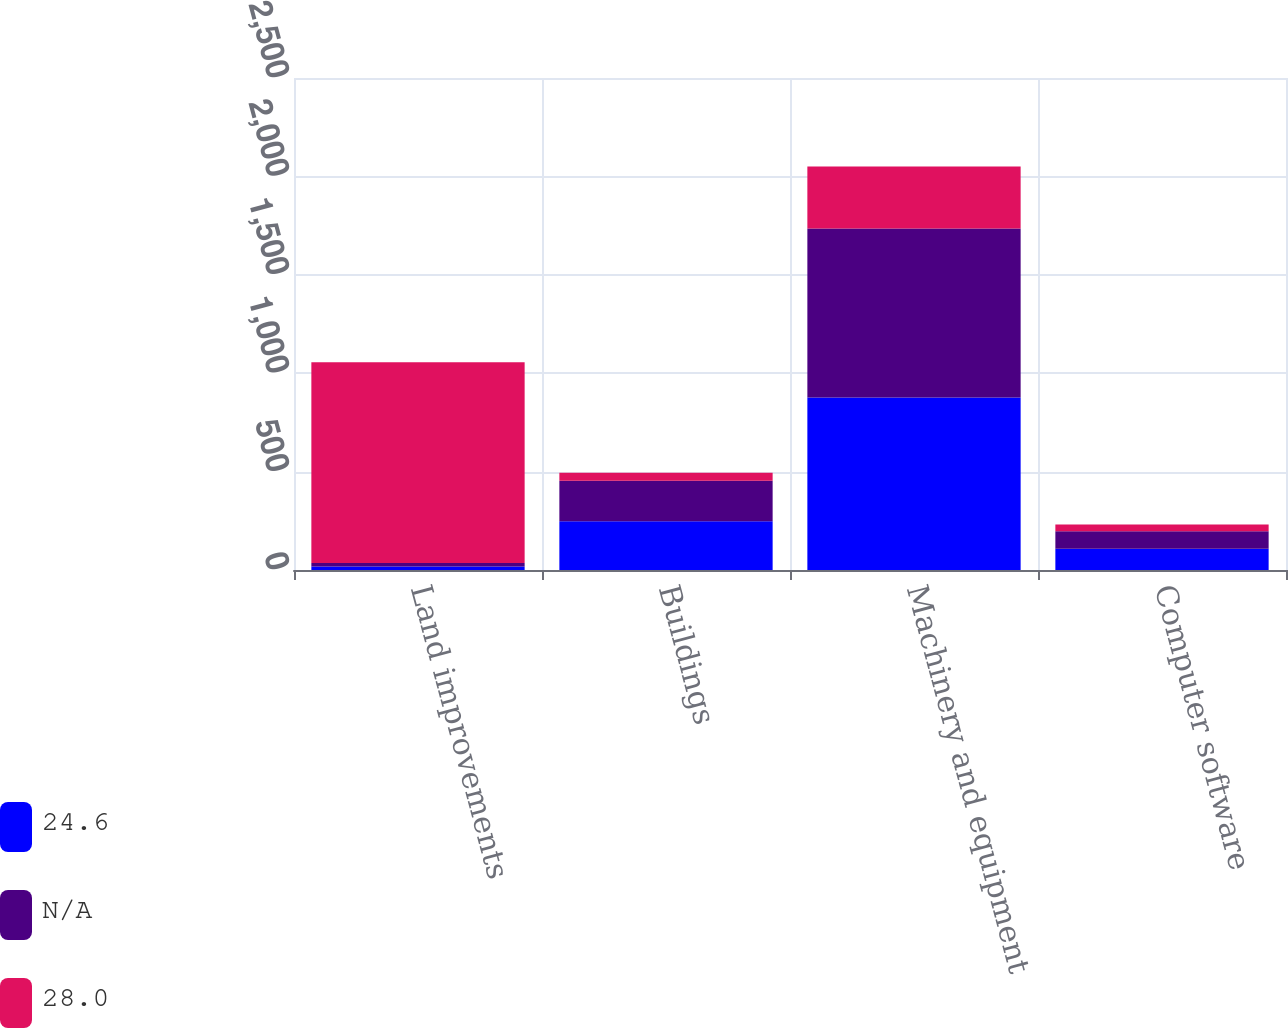<chart> <loc_0><loc_0><loc_500><loc_500><stacked_bar_chart><ecel><fcel>Land improvements<fcel>Buildings<fcel>Machinery and equipment<fcel>Computer software<nl><fcel>24.6<fcel>18<fcel>247.9<fcel>876.9<fcel>108.4<nl><fcel>nan<fcel>18.2<fcel>206.1<fcel>858.5<fcel>87.9<nl><fcel>28<fcel>1020<fcel>40<fcel>315<fcel>35<nl></chart> 